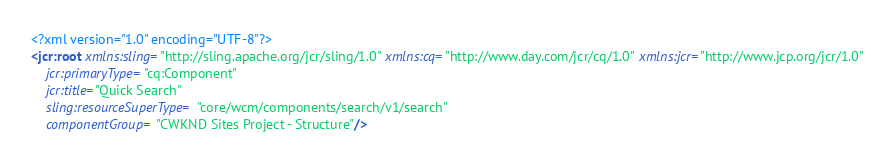Convert code to text. <code><loc_0><loc_0><loc_500><loc_500><_XML_><?xml version="1.0" encoding="UTF-8"?>
<jcr:root xmlns:sling="http://sling.apache.org/jcr/sling/1.0" xmlns:cq="http://www.day.com/jcr/cq/1.0" xmlns:jcr="http://www.jcp.org/jcr/1.0"
    jcr:primaryType="cq:Component"
    jcr:title="Quick Search"
    sling:resourceSuperType="core/wcm/components/search/v1/search"
    componentGroup="CWKND Sites Project - Structure"/>
</code> 